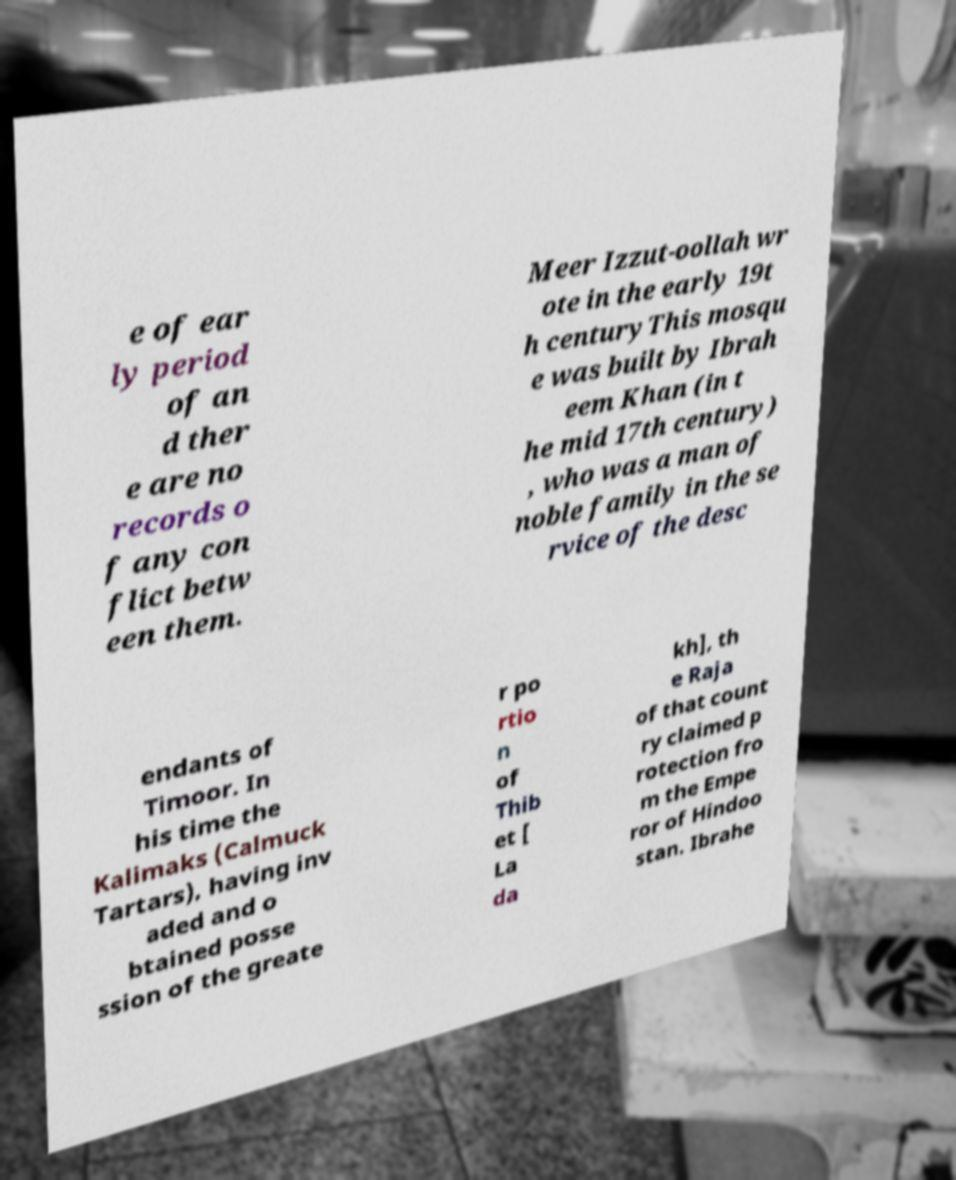For documentation purposes, I need the text within this image transcribed. Could you provide that? e of ear ly period of an d ther e are no records o f any con flict betw een them. Meer Izzut-oollah wr ote in the early 19t h centuryThis mosqu e was built by Ibrah eem Khan (in t he mid 17th century) , who was a man of noble family in the se rvice of the desc endants of Timoor. In his time the Kalimaks (Calmuck Tartars), having inv aded and o btained posse ssion of the greate r po rtio n of Thib et [ La da kh], th e Raja of that count ry claimed p rotection fro m the Empe ror of Hindoo stan. Ibrahe 